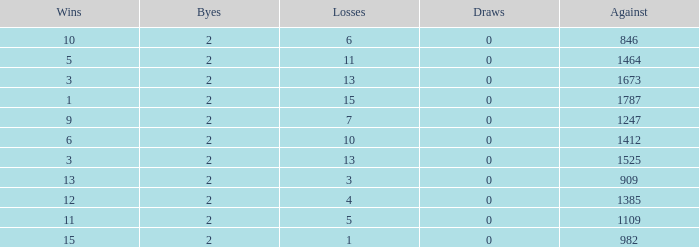What is the number listed under against when there were less than 13 losses and less than 2 byes? 0.0. 